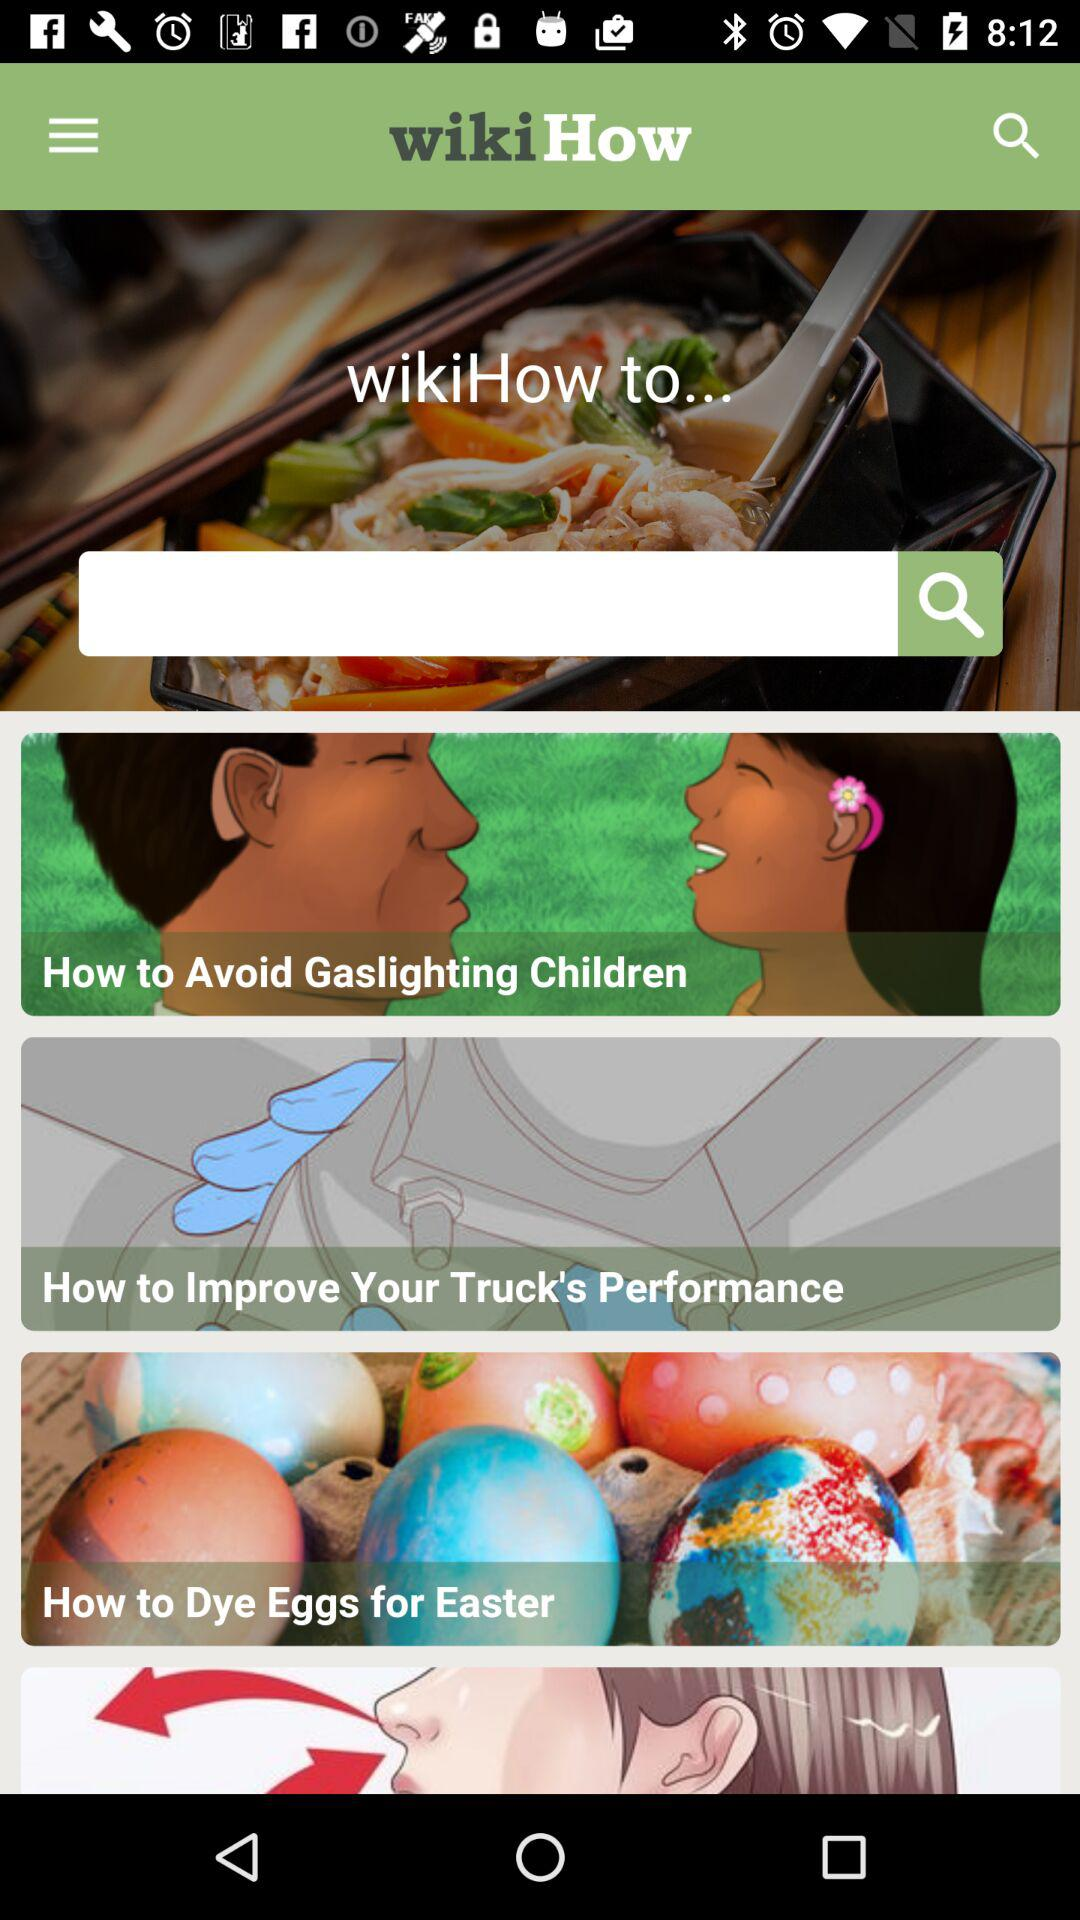What is the name of the application? The name of the application is "wikiHow". 